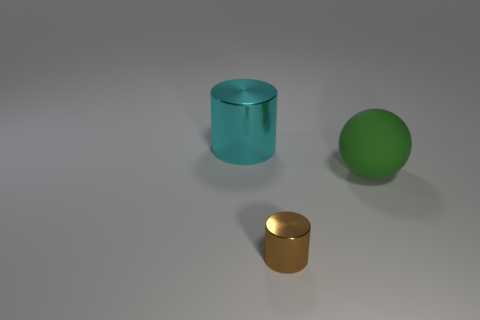What size is the cylinder that is on the left side of the metallic object that is right of the cylinder behind the brown metallic cylinder?
Provide a short and direct response. Large. Do the big thing left of the brown object and the metal cylinder that is in front of the green thing have the same color?
Provide a succinct answer. No. How many cyan objects are either matte spheres or cylinders?
Give a very brief answer. 1. How many cylinders have the same size as the cyan object?
Make the answer very short. 0. Is the material of the cylinder that is behind the large green object the same as the tiny object?
Your answer should be very brief. Yes. Are there any balls that are in front of the metallic cylinder behind the brown metallic thing?
Ensure brevity in your answer.  Yes. What material is the large object that is the same shape as the small brown shiny thing?
Your response must be concise. Metal. Is the number of green objects in front of the cyan metallic thing greater than the number of tiny shiny cylinders that are on the left side of the brown shiny thing?
Ensure brevity in your answer.  Yes. There is another object that is made of the same material as the small brown thing; what shape is it?
Your answer should be very brief. Cylinder. Are there more large cyan metal objects in front of the big cylinder than small yellow things?
Your answer should be very brief. No. 